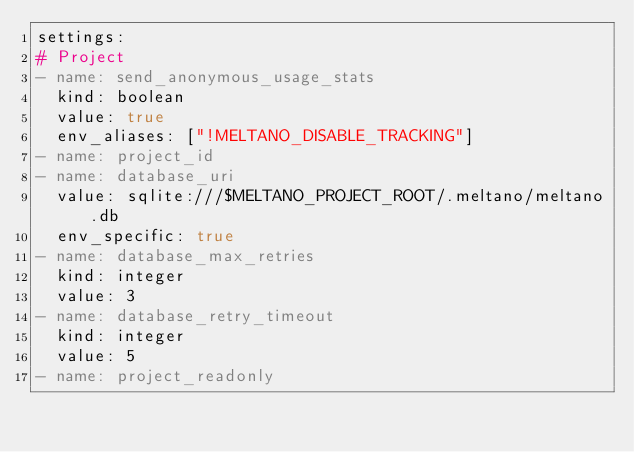<code> <loc_0><loc_0><loc_500><loc_500><_YAML_>settings:
# Project
- name: send_anonymous_usage_stats
  kind: boolean
  value: true
  env_aliases: ["!MELTANO_DISABLE_TRACKING"]
- name: project_id
- name: database_uri
  value: sqlite:///$MELTANO_PROJECT_ROOT/.meltano/meltano.db
  env_specific: true
- name: database_max_retries
  kind: integer
  value: 3
- name: database_retry_timeout
  kind: integer
  value: 5
- name: project_readonly</code> 